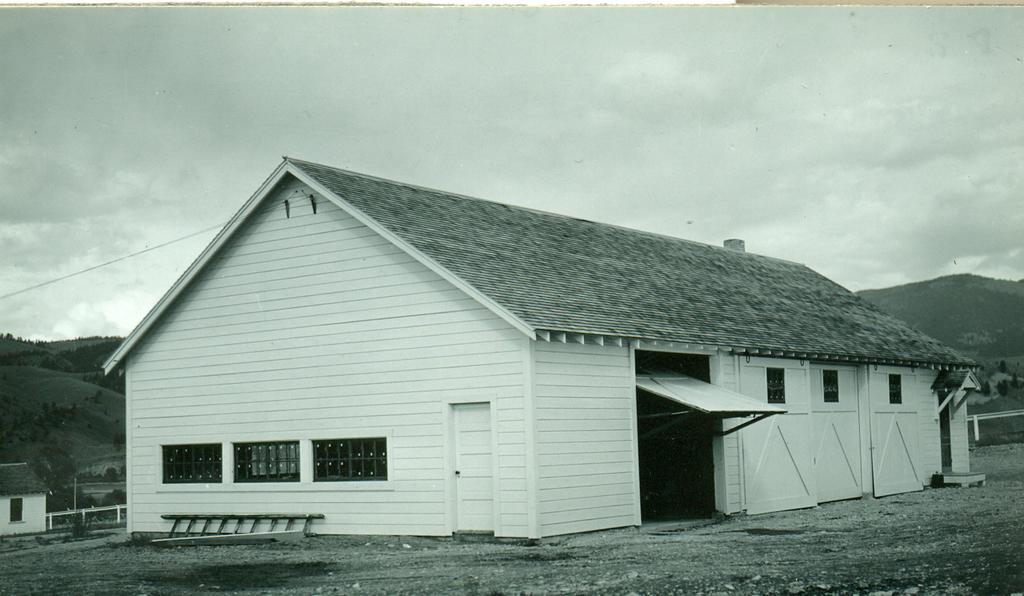In one or two sentences, can you explain what this image depicts? In this image in the front there is a house, in front of the house there is a ladder. On the left side there is a fence and there is a cottage. In the background there are mountains, trees and there is a railing which is white in colour and the sky is cloudy. 